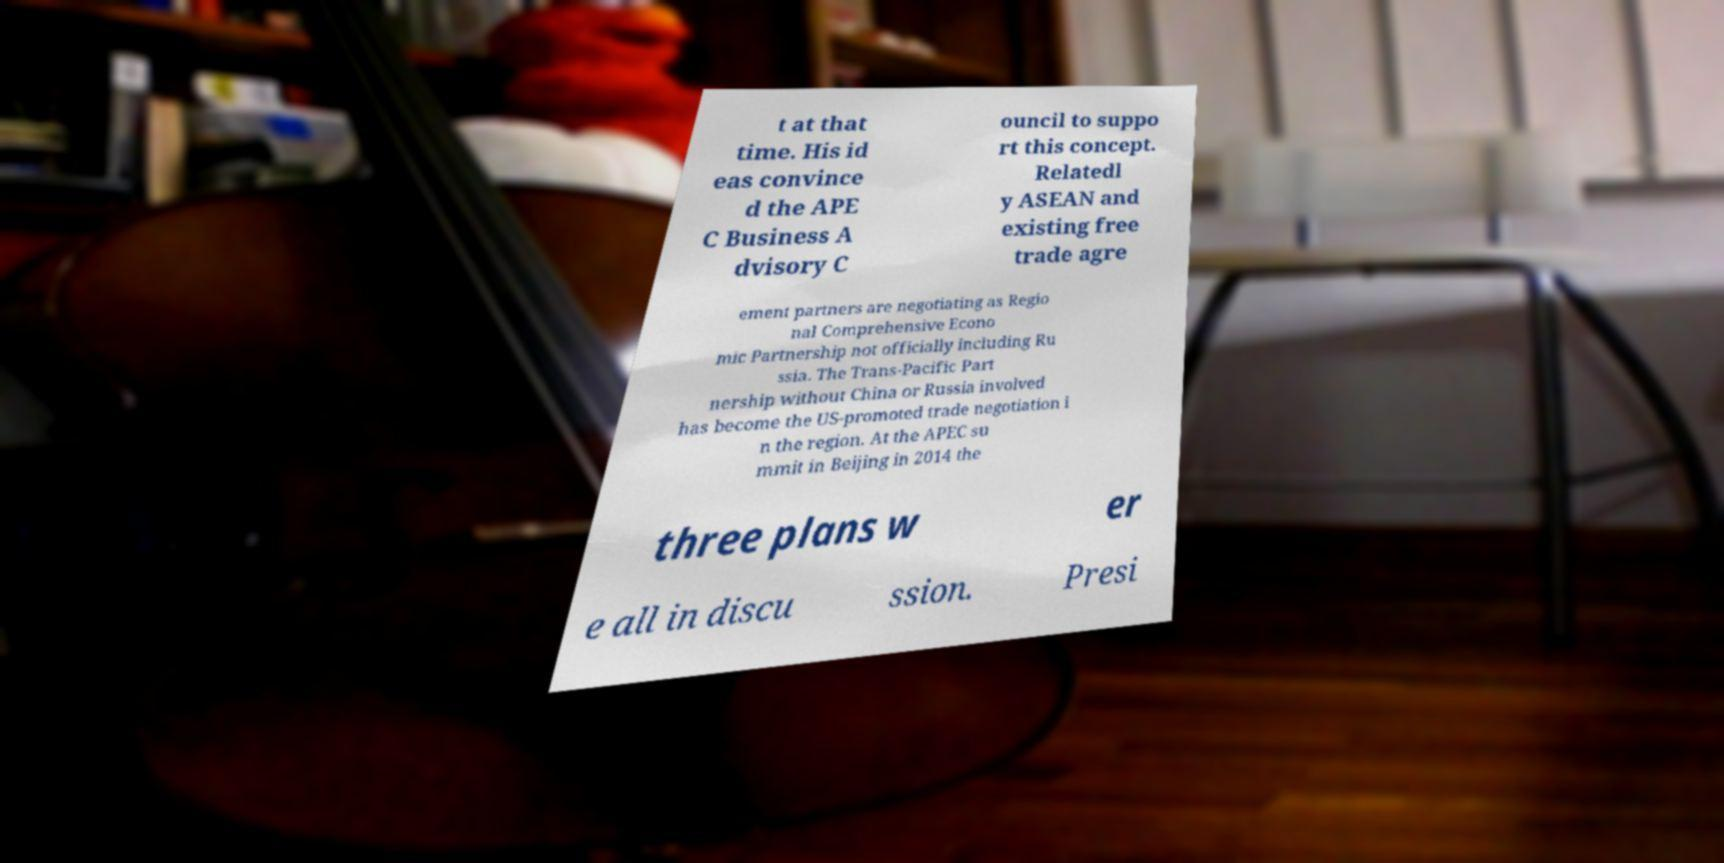What messages or text are displayed in this image? I need them in a readable, typed format. t at that time. His id eas convince d the APE C Business A dvisory C ouncil to suppo rt this concept. Relatedl y ASEAN and existing free trade agre ement partners are negotiating as Regio nal Comprehensive Econo mic Partnership not officially including Ru ssia. The Trans-Pacific Part nership without China or Russia involved has become the US-promoted trade negotiation i n the region. At the APEC su mmit in Beijing in 2014 the three plans w er e all in discu ssion. Presi 